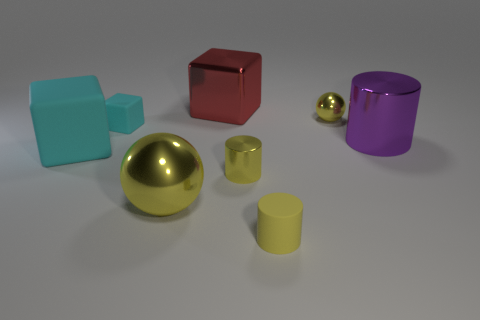Is there anything else that is the same color as the large rubber block?
Ensure brevity in your answer.  Yes. There is a metal ball behind the large sphere; is it the same color as the large metallic object that is in front of the big purple metal cylinder?
Make the answer very short. Yes. What is the size of the other sphere that is the same color as the tiny metallic sphere?
Provide a succinct answer. Large. What number of cylinders are to the right of the large red object?
Provide a succinct answer. 3. There is another cylinder that is the same color as the small rubber cylinder; what is its material?
Provide a short and direct response. Metal. What number of tiny objects are either yellow metallic cylinders or yellow matte objects?
Provide a succinct answer. 2. The yellow metal object that is left of the red metal cube has what shape?
Provide a succinct answer. Sphere. Are there any tiny matte things of the same color as the big matte object?
Keep it short and to the point. Yes. Do the cylinder that is in front of the big metal ball and the cylinder on the right side of the yellow rubber thing have the same size?
Offer a very short reply. No. Are there more shiny objects that are in front of the tiny metal cylinder than large purple metal things to the left of the small cyan rubber cube?
Your answer should be compact. Yes. 